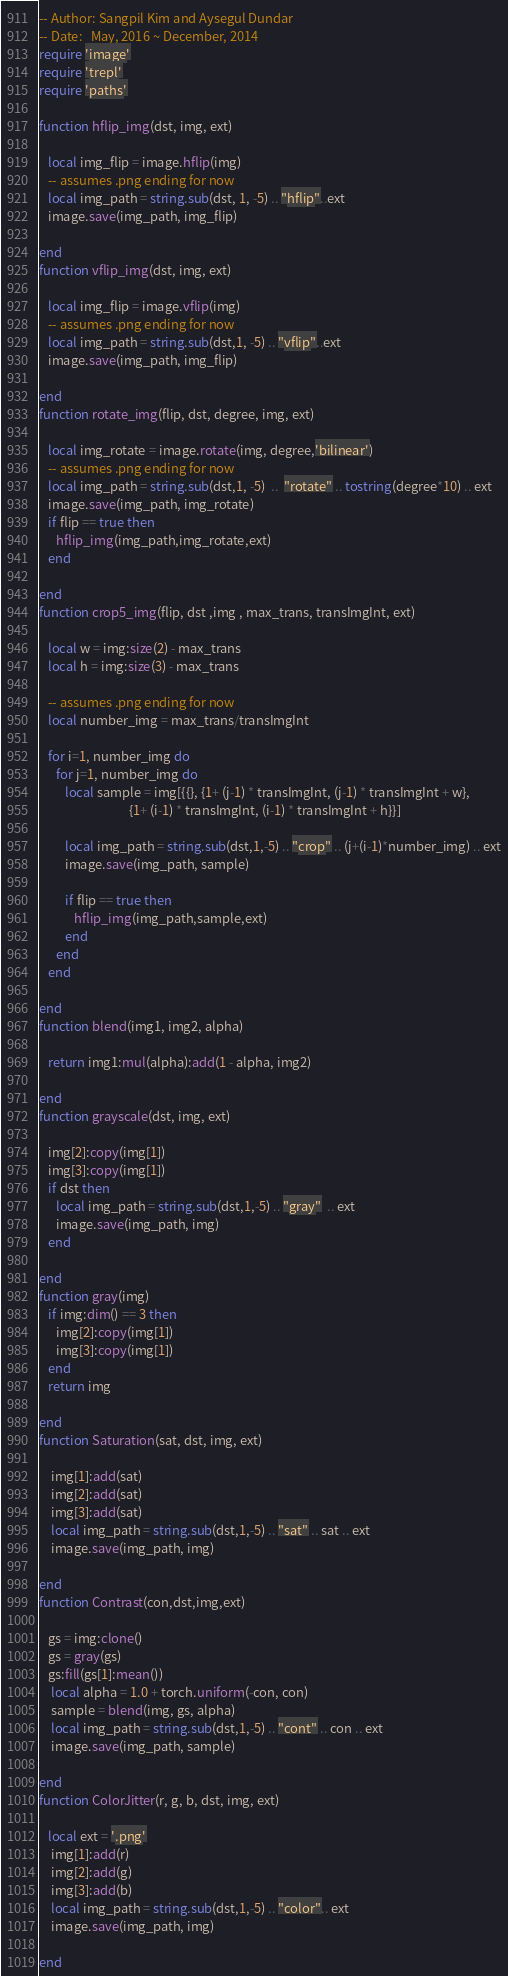<code> <loc_0><loc_0><loc_500><loc_500><_Lua_>-- Author: Sangpil Kim and Aysegul Dundar
-- Date:   May, 2016 ~ December, 2014
require 'image'
require 'trepl'
require 'paths'

function hflip_img(dst, img, ext)

   local img_flip = image.hflip(img)
   -- assumes .png ending for now
   local img_path = string.sub(dst, 1, -5) .. "hflip"..ext
   image.save(img_path, img_flip)

end
function vflip_img(dst, img, ext)

   local img_flip = image.vflip(img)
   -- assumes .png ending for now
   local img_path = string.sub(dst,1, -5) .. "vflip"..ext
   image.save(img_path, img_flip)

end
function rotate_img(flip, dst, degree, img, ext)

   local img_rotate = image.rotate(img, degree,'bilinear')
   -- assumes .png ending for now
   local img_path = string.sub(dst,1, -5)  ..  "rotate" .. tostring(degree*10) .. ext
   image.save(img_path, img_rotate)
   if flip == true then
      hflip_img(img_path,img_rotate,ext)
   end

end
function crop5_img(flip, dst ,img , max_trans, transImgInt, ext)

   local w = img:size(2) - max_trans
   local h = img:size(3) - max_trans

   -- assumes .png ending for now
   local number_img = max_trans/transImgInt

   for i=1, number_img do
      for j=1, number_img do
         local sample = img[{{}, {1+ (j-1) * transImgInt, (j-1) * transImgInt + w},
                               {1+ (i-1) * transImgInt, (i-1) * transImgInt + h}}]

         local img_path = string.sub(dst,1,-5) .. "crop" .. (j+(i-1)*number_img) .. ext
         image.save(img_path, sample)

         if flip == true then
            hflip_img(img_path,sample,ext)
         end
      end
   end

end
function blend(img1, img2, alpha)

   return img1:mul(alpha):add(1 - alpha, img2)

end
function grayscale(dst, img, ext)

   img[2]:copy(img[1])
   img[3]:copy(img[1])
   if dst then
      local img_path = string.sub(dst,1,-5) .. "gray"  .. ext
      image.save(img_path, img)
   end

end
function gray(img)
   if img:dim() == 3 then
      img[2]:copy(img[1])
      img[3]:copy(img[1])
   end
   return img

end
function Saturation(sat, dst, img, ext)

	img[1]:add(sat)
	img[2]:add(sat)
	img[3]:add(sat)
	local img_path = string.sub(dst,1,-5) .. "sat" .. sat .. ext
	image.save(img_path, img)

end
function Contrast(con,dst,img,ext)

   gs = img:clone()
   gs = gray(gs)
   gs:fill(gs[1]:mean())
	local alpha = 1.0 + torch.uniform(-con, con)
	sample = blend(img, gs, alpha)
	local img_path = string.sub(dst,1,-5) .. "cont" .. con .. ext
	image.save(img_path, sample)

end
function ColorJitter(r, g, b, dst, img, ext)

   local ext = '.png'
	img[1]:add(r)
	img[2]:add(g)
	img[3]:add(b)
	local img_path = string.sub(dst,1,-5) .. "color".. ext
	image.save(img_path, img)

end
</code> 